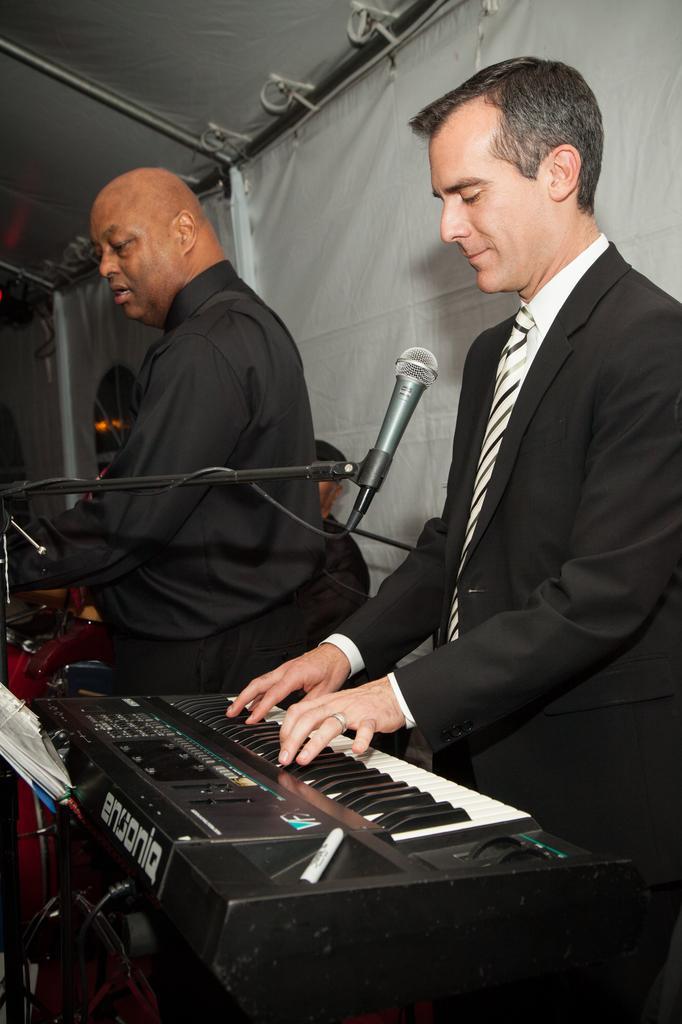How would you summarize this image in a sentence or two? In this picture we can see man wore blazer, tie playing piano and here person is standing and in front of him there is a mic and in the background we can see tent with cloth. 